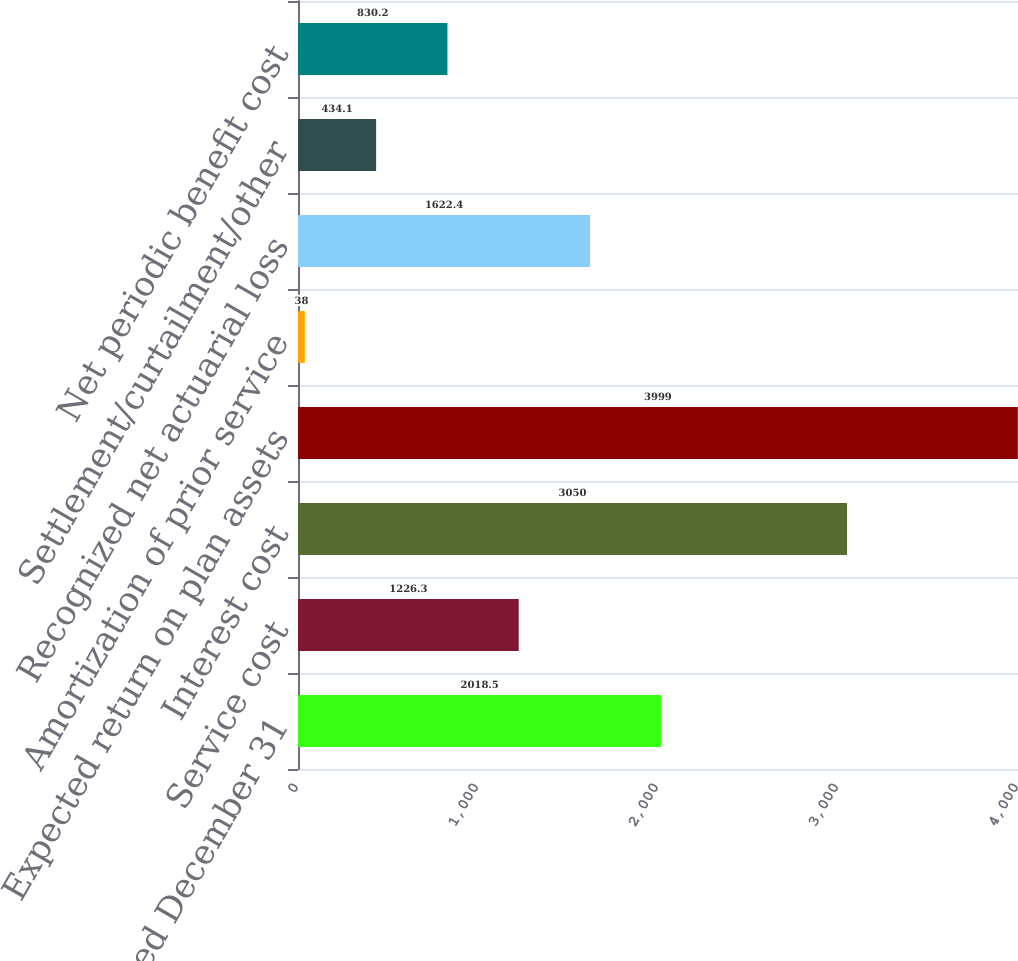Convert chart to OTSL. <chart><loc_0><loc_0><loc_500><loc_500><bar_chart><fcel>Years ended December 31<fcel>Service cost<fcel>Interest cost<fcel>Expected return on plan assets<fcel>Amortization of prior service<fcel>Recognized net actuarial loss<fcel>Settlement/curtailment/other<fcel>Net periodic benefit cost<nl><fcel>2018.5<fcel>1226.3<fcel>3050<fcel>3999<fcel>38<fcel>1622.4<fcel>434.1<fcel>830.2<nl></chart> 